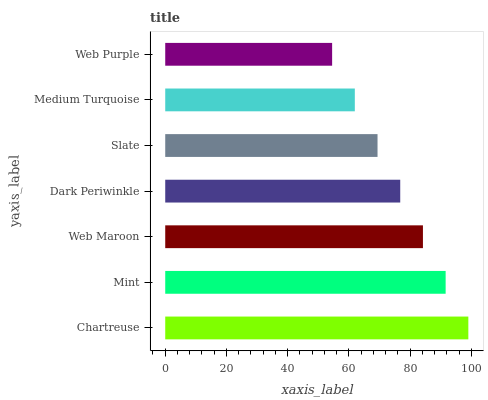Is Web Purple the minimum?
Answer yes or no. Yes. Is Chartreuse the maximum?
Answer yes or no. Yes. Is Mint the minimum?
Answer yes or no. No. Is Mint the maximum?
Answer yes or no. No. Is Chartreuse greater than Mint?
Answer yes or no. Yes. Is Mint less than Chartreuse?
Answer yes or no. Yes. Is Mint greater than Chartreuse?
Answer yes or no. No. Is Chartreuse less than Mint?
Answer yes or no. No. Is Dark Periwinkle the high median?
Answer yes or no. Yes. Is Dark Periwinkle the low median?
Answer yes or no. Yes. Is Web Maroon the high median?
Answer yes or no. No. Is Web Purple the low median?
Answer yes or no. No. 